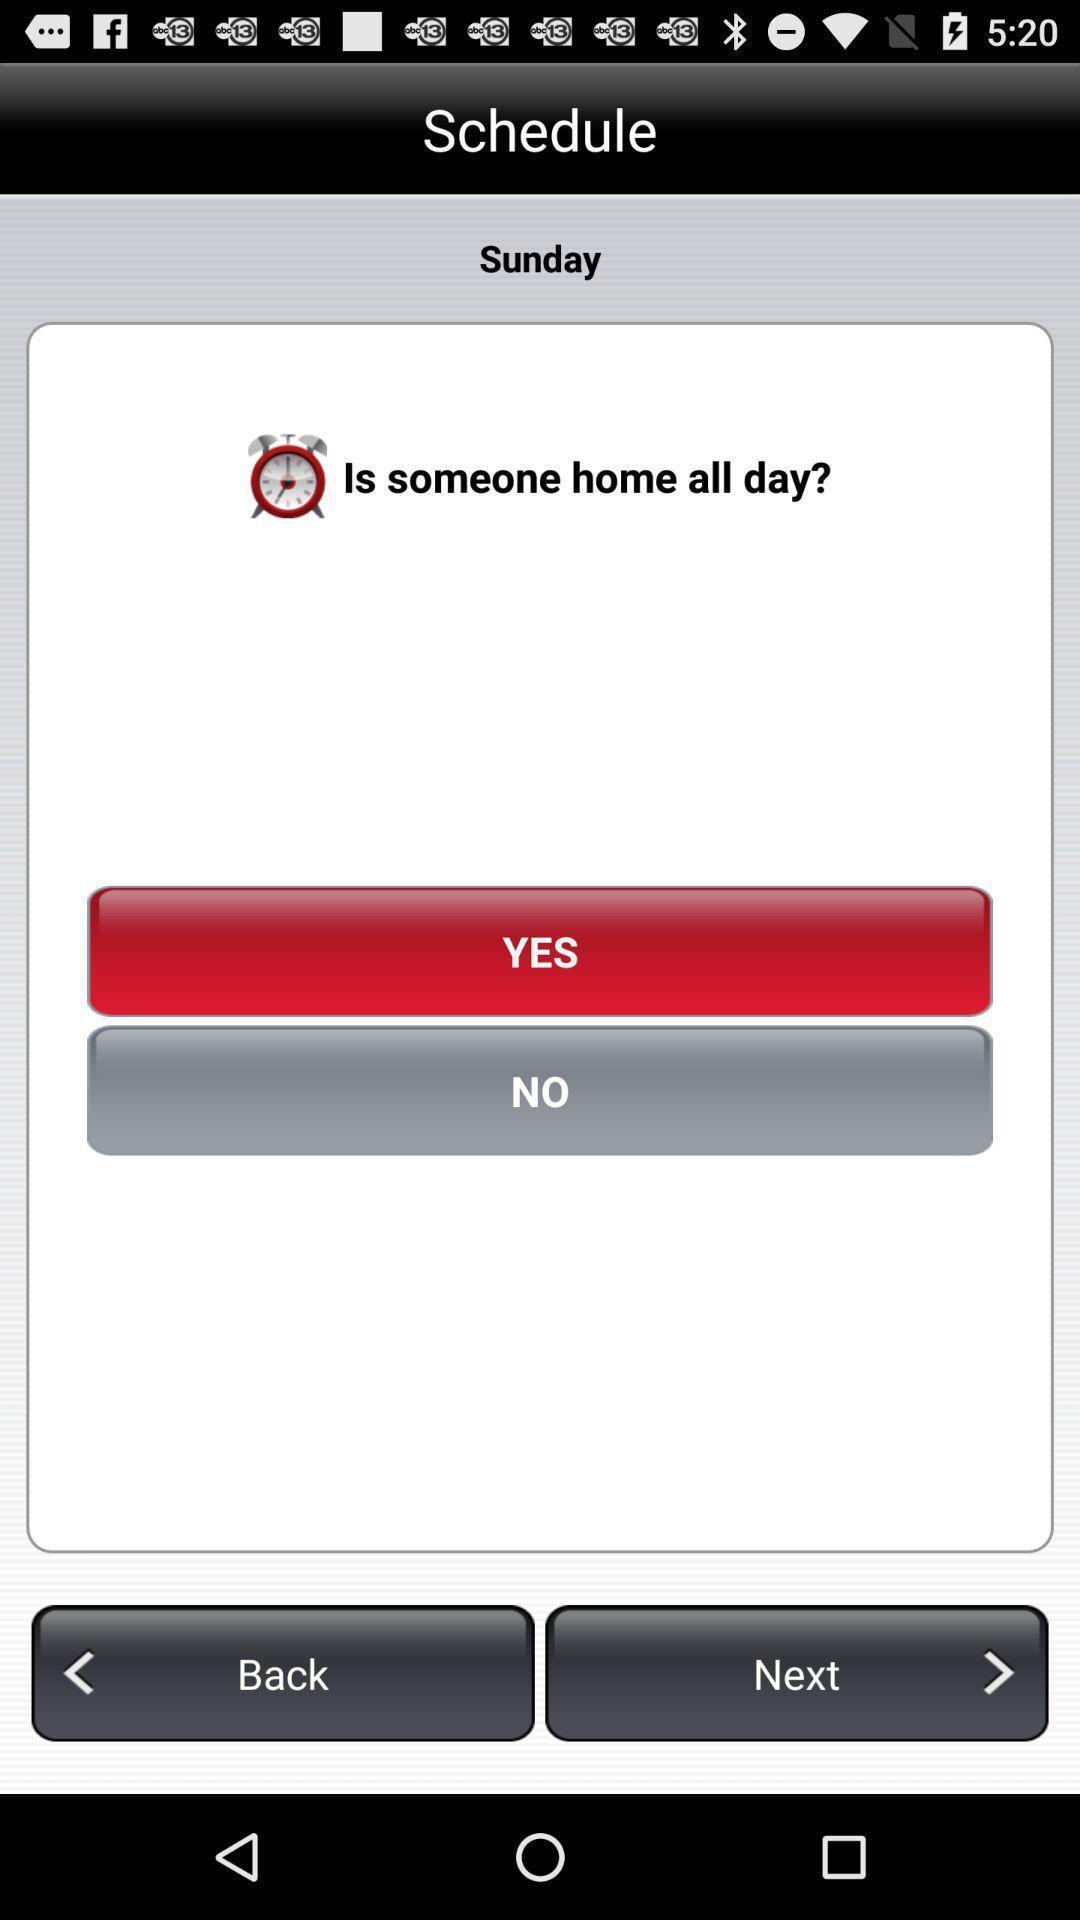Provide a detailed account of this screenshot. Screen displaying the schedule page. 